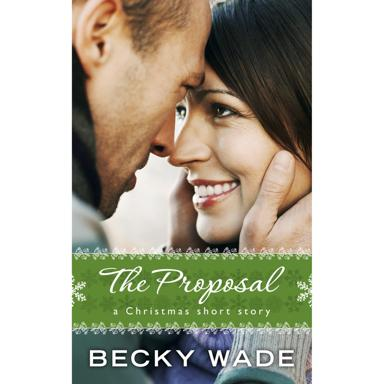What is the setting of the image? The photo captures an intimate moment between a man and a woman who are in close proximity, exchanging a tender gaze that suggests a deep emotional connection. The presence of the green banner with delicate snowflake designs above them infers that the scene could be set during the holiday season, likely reflecting the Christmas context of the short story titled 'The Proposal,' as mentioned in the text overlaid on the image. 